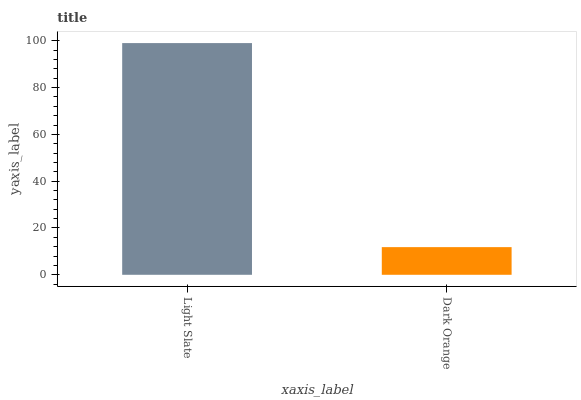Is Dark Orange the minimum?
Answer yes or no. Yes. Is Light Slate the maximum?
Answer yes or no. Yes. Is Dark Orange the maximum?
Answer yes or no. No. Is Light Slate greater than Dark Orange?
Answer yes or no. Yes. Is Dark Orange less than Light Slate?
Answer yes or no. Yes. Is Dark Orange greater than Light Slate?
Answer yes or no. No. Is Light Slate less than Dark Orange?
Answer yes or no. No. Is Light Slate the high median?
Answer yes or no. Yes. Is Dark Orange the low median?
Answer yes or no. Yes. Is Dark Orange the high median?
Answer yes or no. No. Is Light Slate the low median?
Answer yes or no. No. 